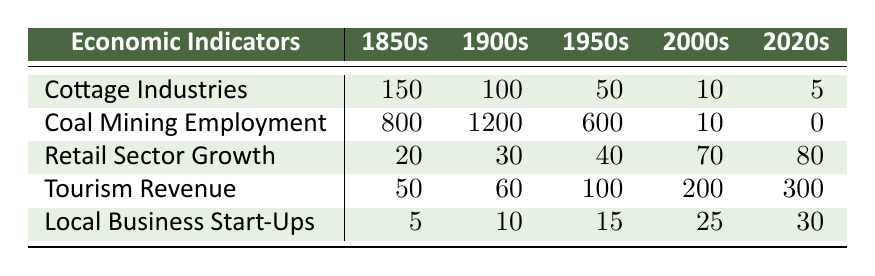What was the highest Coal Mining Employment recorded? The table indicates Coal Mining Employment for the 1900s was 1200, which is higher than all other periods listed.
Answer: 1200 How much did Cottage Industries decline from the 1850s to the 2020s? In the 1850s, Cottage Industries had 150, and in the 2020s, it had 5. The decline is calculated as 150 - 5 = 145.
Answer: 145 Is it true that Tourism Revenue increased in every decade from the 1850s to the 2020s? Checking the values: 1850s (50), 1900s (60), 1950s (100), 2000s (200), and 2020s (300). Each subsequent decade shows an increase, confirming the statement is true.
Answer: Yes What was the total Retail Sector Growth from 1850s to 2020s? Adding the Retail Sector Growth values: 20 + 30 + 40 + 70 + 80 gives a total of 240.
Answer: 240 In which decade did Local Business Start-Ups see the most significant increase? Comparing the values: 1850s (5), 1900s (10), 1950s (15), 2000s (25), 2020s (30). The largest increase occurred from the 2000s to the 2020s (5), representing a rise from 25 to 30.
Answer: 2000s to 2020s How many more people were employed in Coal Mining in the 1900s compared to the 1950s? The 1900s had 1200 employed while the 1950s had 600. The difference is calculated as 1200 - 600 = 600, indicating more employment in 1900s.
Answer: 600 What was the average Tourism Revenue across the decades? Adding the values for Tourism Revenue yields 50 + 60 + 100 + 200 + 300 = 710. Dividing by 5 gives an average of 710 / 5 = 142.
Answer: 142 Did Retail Sector Growth ever exceed 70 in the observed decades? Looking through the values, Retail Sector Growth exceeded 70 only in the 2000s (70) and in the 2020s (80), hence the statement is true.
Answer: Yes What is the percentage decline of Coal Mining Employment from the 1850s to the 2020s? The initial employment was 800 in 1850s and reduced to 0 by the 2020s. The decline is 800 - 0 = 800. The percentage decline is calculated as (800 / 800) * 100 = 100%.
Answer: 100% 